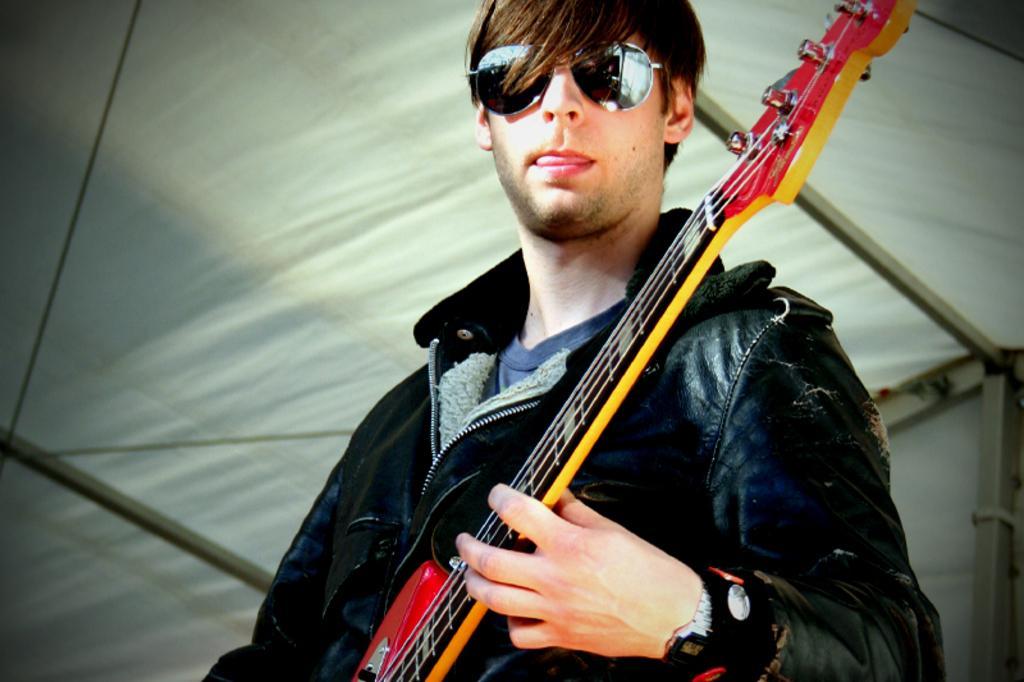Can you describe this image briefly? This picture shows a man standing and playing guitar and he wore sunglasses on his face 